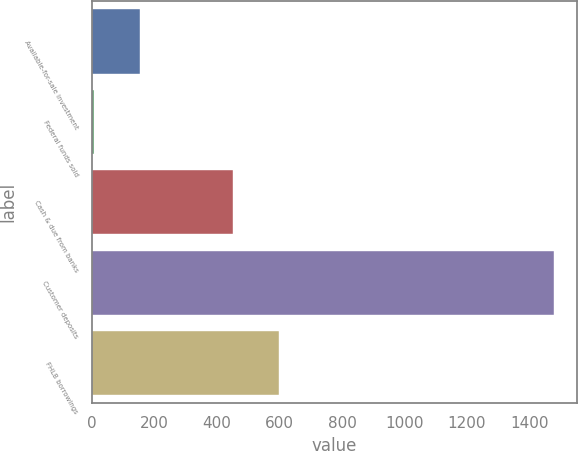Convert chart to OTSL. <chart><loc_0><loc_0><loc_500><loc_500><bar_chart><fcel>Available-for-sale investment<fcel>Federal funds sold<fcel>Cash & due from banks<fcel>Customer deposits<fcel>FHLB borrowings<nl><fcel>153.2<fcel>6<fcel>450<fcel>1478<fcel>597.2<nl></chart> 